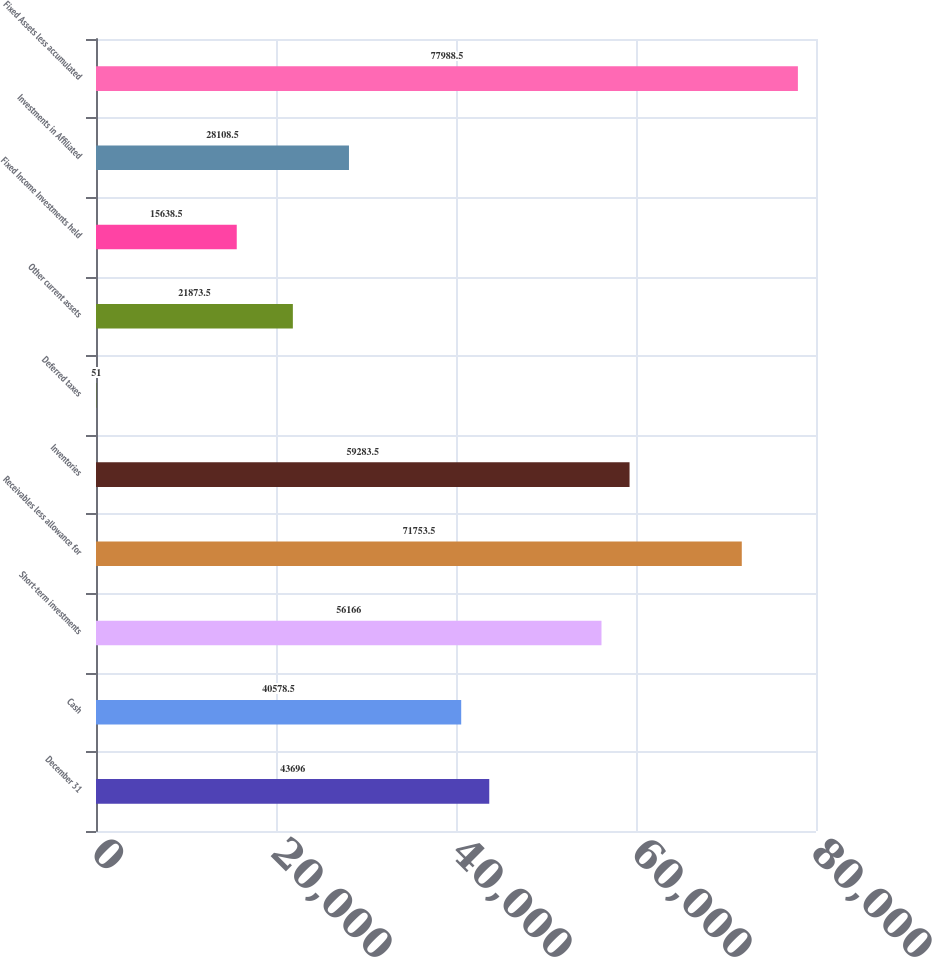<chart> <loc_0><loc_0><loc_500><loc_500><bar_chart><fcel>December 31<fcel>Cash<fcel>Short-term investments<fcel>Receivables less allowance for<fcel>Inventories<fcel>Deferred taxes<fcel>Other current assets<fcel>Fixed Income Investments held<fcel>Investments in Affiliated<fcel>Fixed Assets less accumulated<nl><fcel>43696<fcel>40578.5<fcel>56166<fcel>71753.5<fcel>59283.5<fcel>51<fcel>21873.5<fcel>15638.5<fcel>28108.5<fcel>77988.5<nl></chart> 